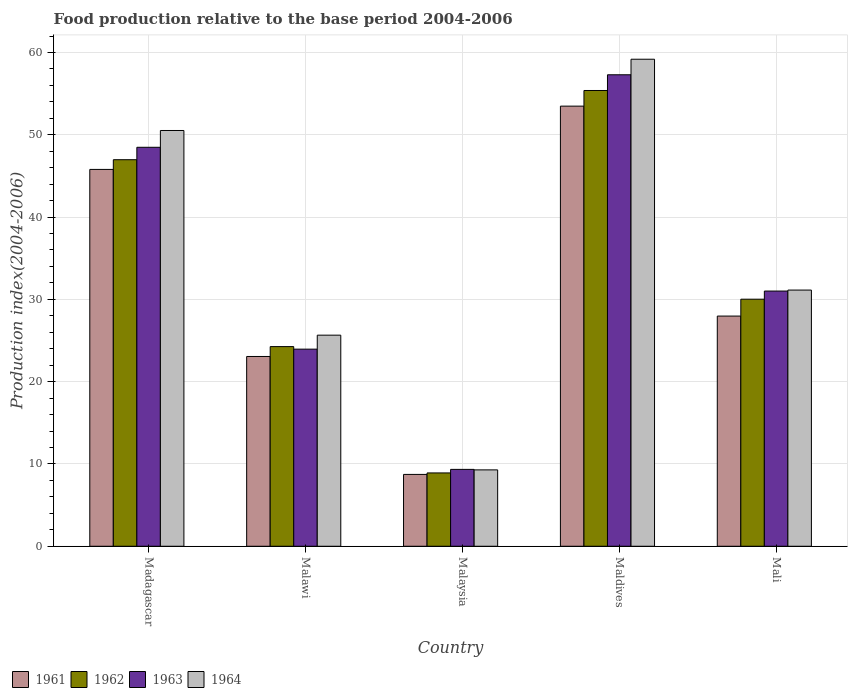How many different coloured bars are there?
Provide a succinct answer. 4. Are the number of bars per tick equal to the number of legend labels?
Provide a short and direct response. Yes. How many bars are there on the 4th tick from the left?
Provide a short and direct response. 4. What is the label of the 1st group of bars from the left?
Give a very brief answer. Madagascar. What is the food production index in 1962 in Malawi?
Provide a short and direct response. 24.26. Across all countries, what is the maximum food production index in 1961?
Provide a short and direct response. 53.48. Across all countries, what is the minimum food production index in 1961?
Offer a very short reply. 8.73. In which country was the food production index in 1961 maximum?
Ensure brevity in your answer.  Maldives. In which country was the food production index in 1961 minimum?
Your response must be concise. Malaysia. What is the total food production index in 1963 in the graph?
Provide a short and direct response. 170.07. What is the difference between the food production index in 1963 in Madagascar and that in Maldives?
Offer a terse response. -8.81. What is the difference between the food production index in 1961 in Madagascar and the food production index in 1962 in Mali?
Ensure brevity in your answer.  15.77. What is the average food production index in 1962 per country?
Your answer should be compact. 33.11. What is the difference between the food production index of/in 1964 and food production index of/in 1961 in Maldives?
Provide a succinct answer. 5.7. In how many countries, is the food production index in 1963 greater than 44?
Make the answer very short. 2. What is the ratio of the food production index in 1961 in Madagascar to that in Maldives?
Ensure brevity in your answer.  0.86. What is the difference between the highest and the second highest food production index in 1962?
Your response must be concise. -16.95. What is the difference between the highest and the lowest food production index in 1961?
Provide a succinct answer. 44.75. What does the 3rd bar from the left in Mali represents?
Make the answer very short. 1963. How many bars are there?
Give a very brief answer. 20. How many countries are there in the graph?
Offer a very short reply. 5. What is the difference between two consecutive major ticks on the Y-axis?
Your answer should be compact. 10. Where does the legend appear in the graph?
Give a very brief answer. Bottom left. What is the title of the graph?
Your answer should be very brief. Food production relative to the base period 2004-2006. What is the label or title of the X-axis?
Keep it short and to the point. Country. What is the label or title of the Y-axis?
Provide a short and direct response. Production index(2004-2006). What is the Production index(2004-2006) in 1961 in Madagascar?
Provide a short and direct response. 45.79. What is the Production index(2004-2006) of 1962 in Madagascar?
Make the answer very short. 46.97. What is the Production index(2004-2006) of 1963 in Madagascar?
Ensure brevity in your answer.  48.48. What is the Production index(2004-2006) of 1964 in Madagascar?
Ensure brevity in your answer.  50.52. What is the Production index(2004-2006) in 1961 in Malawi?
Give a very brief answer. 23.06. What is the Production index(2004-2006) in 1962 in Malawi?
Keep it short and to the point. 24.26. What is the Production index(2004-2006) of 1963 in Malawi?
Your answer should be compact. 23.95. What is the Production index(2004-2006) in 1964 in Malawi?
Provide a short and direct response. 25.65. What is the Production index(2004-2006) of 1961 in Malaysia?
Your answer should be compact. 8.73. What is the Production index(2004-2006) of 1962 in Malaysia?
Make the answer very short. 8.91. What is the Production index(2004-2006) of 1963 in Malaysia?
Your answer should be very brief. 9.34. What is the Production index(2004-2006) in 1964 in Malaysia?
Keep it short and to the point. 9.28. What is the Production index(2004-2006) in 1961 in Maldives?
Offer a very short reply. 53.48. What is the Production index(2004-2006) in 1962 in Maldives?
Keep it short and to the point. 55.38. What is the Production index(2004-2006) in 1963 in Maldives?
Your answer should be very brief. 57.29. What is the Production index(2004-2006) in 1964 in Maldives?
Make the answer very short. 59.18. What is the Production index(2004-2006) in 1961 in Mali?
Your response must be concise. 27.97. What is the Production index(2004-2006) of 1962 in Mali?
Keep it short and to the point. 30.02. What is the Production index(2004-2006) of 1963 in Mali?
Offer a terse response. 31.01. What is the Production index(2004-2006) in 1964 in Mali?
Offer a terse response. 31.13. Across all countries, what is the maximum Production index(2004-2006) of 1961?
Your response must be concise. 53.48. Across all countries, what is the maximum Production index(2004-2006) in 1962?
Make the answer very short. 55.38. Across all countries, what is the maximum Production index(2004-2006) of 1963?
Your answer should be compact. 57.29. Across all countries, what is the maximum Production index(2004-2006) in 1964?
Give a very brief answer. 59.18. Across all countries, what is the minimum Production index(2004-2006) in 1961?
Give a very brief answer. 8.73. Across all countries, what is the minimum Production index(2004-2006) of 1962?
Make the answer very short. 8.91. Across all countries, what is the minimum Production index(2004-2006) in 1963?
Your answer should be compact. 9.34. Across all countries, what is the minimum Production index(2004-2006) of 1964?
Give a very brief answer. 9.28. What is the total Production index(2004-2006) of 1961 in the graph?
Make the answer very short. 159.03. What is the total Production index(2004-2006) in 1962 in the graph?
Give a very brief answer. 165.54. What is the total Production index(2004-2006) in 1963 in the graph?
Your answer should be very brief. 170.07. What is the total Production index(2004-2006) of 1964 in the graph?
Ensure brevity in your answer.  175.76. What is the difference between the Production index(2004-2006) of 1961 in Madagascar and that in Malawi?
Provide a short and direct response. 22.73. What is the difference between the Production index(2004-2006) in 1962 in Madagascar and that in Malawi?
Make the answer very short. 22.71. What is the difference between the Production index(2004-2006) in 1963 in Madagascar and that in Malawi?
Keep it short and to the point. 24.53. What is the difference between the Production index(2004-2006) of 1964 in Madagascar and that in Malawi?
Give a very brief answer. 24.87. What is the difference between the Production index(2004-2006) of 1961 in Madagascar and that in Malaysia?
Make the answer very short. 37.06. What is the difference between the Production index(2004-2006) in 1962 in Madagascar and that in Malaysia?
Offer a terse response. 38.06. What is the difference between the Production index(2004-2006) of 1963 in Madagascar and that in Malaysia?
Your answer should be compact. 39.14. What is the difference between the Production index(2004-2006) in 1964 in Madagascar and that in Malaysia?
Your answer should be very brief. 41.24. What is the difference between the Production index(2004-2006) of 1961 in Madagascar and that in Maldives?
Give a very brief answer. -7.69. What is the difference between the Production index(2004-2006) in 1962 in Madagascar and that in Maldives?
Your answer should be compact. -8.41. What is the difference between the Production index(2004-2006) in 1963 in Madagascar and that in Maldives?
Provide a short and direct response. -8.81. What is the difference between the Production index(2004-2006) in 1964 in Madagascar and that in Maldives?
Keep it short and to the point. -8.66. What is the difference between the Production index(2004-2006) of 1961 in Madagascar and that in Mali?
Ensure brevity in your answer.  17.82. What is the difference between the Production index(2004-2006) in 1962 in Madagascar and that in Mali?
Ensure brevity in your answer.  16.95. What is the difference between the Production index(2004-2006) in 1963 in Madagascar and that in Mali?
Ensure brevity in your answer.  17.47. What is the difference between the Production index(2004-2006) in 1964 in Madagascar and that in Mali?
Provide a succinct answer. 19.39. What is the difference between the Production index(2004-2006) of 1961 in Malawi and that in Malaysia?
Make the answer very short. 14.33. What is the difference between the Production index(2004-2006) in 1962 in Malawi and that in Malaysia?
Give a very brief answer. 15.35. What is the difference between the Production index(2004-2006) of 1963 in Malawi and that in Malaysia?
Your answer should be compact. 14.61. What is the difference between the Production index(2004-2006) in 1964 in Malawi and that in Malaysia?
Offer a terse response. 16.37. What is the difference between the Production index(2004-2006) of 1961 in Malawi and that in Maldives?
Offer a terse response. -30.42. What is the difference between the Production index(2004-2006) of 1962 in Malawi and that in Maldives?
Provide a succinct answer. -31.12. What is the difference between the Production index(2004-2006) of 1963 in Malawi and that in Maldives?
Make the answer very short. -33.34. What is the difference between the Production index(2004-2006) in 1964 in Malawi and that in Maldives?
Provide a short and direct response. -33.53. What is the difference between the Production index(2004-2006) of 1961 in Malawi and that in Mali?
Provide a succinct answer. -4.91. What is the difference between the Production index(2004-2006) of 1962 in Malawi and that in Mali?
Make the answer very short. -5.76. What is the difference between the Production index(2004-2006) of 1963 in Malawi and that in Mali?
Make the answer very short. -7.06. What is the difference between the Production index(2004-2006) in 1964 in Malawi and that in Mali?
Ensure brevity in your answer.  -5.48. What is the difference between the Production index(2004-2006) in 1961 in Malaysia and that in Maldives?
Your response must be concise. -44.75. What is the difference between the Production index(2004-2006) of 1962 in Malaysia and that in Maldives?
Offer a terse response. -46.47. What is the difference between the Production index(2004-2006) of 1963 in Malaysia and that in Maldives?
Provide a short and direct response. -47.95. What is the difference between the Production index(2004-2006) of 1964 in Malaysia and that in Maldives?
Keep it short and to the point. -49.9. What is the difference between the Production index(2004-2006) of 1961 in Malaysia and that in Mali?
Keep it short and to the point. -19.24. What is the difference between the Production index(2004-2006) in 1962 in Malaysia and that in Mali?
Make the answer very short. -21.11. What is the difference between the Production index(2004-2006) in 1963 in Malaysia and that in Mali?
Your answer should be very brief. -21.67. What is the difference between the Production index(2004-2006) of 1964 in Malaysia and that in Mali?
Keep it short and to the point. -21.85. What is the difference between the Production index(2004-2006) of 1961 in Maldives and that in Mali?
Ensure brevity in your answer.  25.51. What is the difference between the Production index(2004-2006) of 1962 in Maldives and that in Mali?
Give a very brief answer. 25.36. What is the difference between the Production index(2004-2006) of 1963 in Maldives and that in Mali?
Ensure brevity in your answer.  26.28. What is the difference between the Production index(2004-2006) of 1964 in Maldives and that in Mali?
Keep it short and to the point. 28.05. What is the difference between the Production index(2004-2006) of 1961 in Madagascar and the Production index(2004-2006) of 1962 in Malawi?
Provide a short and direct response. 21.53. What is the difference between the Production index(2004-2006) in 1961 in Madagascar and the Production index(2004-2006) in 1963 in Malawi?
Keep it short and to the point. 21.84. What is the difference between the Production index(2004-2006) of 1961 in Madagascar and the Production index(2004-2006) of 1964 in Malawi?
Provide a succinct answer. 20.14. What is the difference between the Production index(2004-2006) in 1962 in Madagascar and the Production index(2004-2006) in 1963 in Malawi?
Offer a terse response. 23.02. What is the difference between the Production index(2004-2006) in 1962 in Madagascar and the Production index(2004-2006) in 1964 in Malawi?
Your answer should be very brief. 21.32. What is the difference between the Production index(2004-2006) of 1963 in Madagascar and the Production index(2004-2006) of 1964 in Malawi?
Your answer should be compact. 22.83. What is the difference between the Production index(2004-2006) of 1961 in Madagascar and the Production index(2004-2006) of 1962 in Malaysia?
Keep it short and to the point. 36.88. What is the difference between the Production index(2004-2006) in 1961 in Madagascar and the Production index(2004-2006) in 1963 in Malaysia?
Provide a short and direct response. 36.45. What is the difference between the Production index(2004-2006) of 1961 in Madagascar and the Production index(2004-2006) of 1964 in Malaysia?
Ensure brevity in your answer.  36.51. What is the difference between the Production index(2004-2006) of 1962 in Madagascar and the Production index(2004-2006) of 1963 in Malaysia?
Provide a succinct answer. 37.63. What is the difference between the Production index(2004-2006) in 1962 in Madagascar and the Production index(2004-2006) in 1964 in Malaysia?
Give a very brief answer. 37.69. What is the difference between the Production index(2004-2006) in 1963 in Madagascar and the Production index(2004-2006) in 1964 in Malaysia?
Your response must be concise. 39.2. What is the difference between the Production index(2004-2006) in 1961 in Madagascar and the Production index(2004-2006) in 1962 in Maldives?
Provide a succinct answer. -9.59. What is the difference between the Production index(2004-2006) of 1961 in Madagascar and the Production index(2004-2006) of 1964 in Maldives?
Give a very brief answer. -13.39. What is the difference between the Production index(2004-2006) of 1962 in Madagascar and the Production index(2004-2006) of 1963 in Maldives?
Your response must be concise. -10.32. What is the difference between the Production index(2004-2006) in 1962 in Madagascar and the Production index(2004-2006) in 1964 in Maldives?
Keep it short and to the point. -12.21. What is the difference between the Production index(2004-2006) of 1961 in Madagascar and the Production index(2004-2006) of 1962 in Mali?
Your response must be concise. 15.77. What is the difference between the Production index(2004-2006) of 1961 in Madagascar and the Production index(2004-2006) of 1963 in Mali?
Make the answer very short. 14.78. What is the difference between the Production index(2004-2006) of 1961 in Madagascar and the Production index(2004-2006) of 1964 in Mali?
Provide a short and direct response. 14.66. What is the difference between the Production index(2004-2006) in 1962 in Madagascar and the Production index(2004-2006) in 1963 in Mali?
Provide a succinct answer. 15.96. What is the difference between the Production index(2004-2006) in 1962 in Madagascar and the Production index(2004-2006) in 1964 in Mali?
Make the answer very short. 15.84. What is the difference between the Production index(2004-2006) in 1963 in Madagascar and the Production index(2004-2006) in 1964 in Mali?
Provide a short and direct response. 17.35. What is the difference between the Production index(2004-2006) of 1961 in Malawi and the Production index(2004-2006) of 1962 in Malaysia?
Your response must be concise. 14.15. What is the difference between the Production index(2004-2006) of 1961 in Malawi and the Production index(2004-2006) of 1963 in Malaysia?
Give a very brief answer. 13.72. What is the difference between the Production index(2004-2006) of 1961 in Malawi and the Production index(2004-2006) of 1964 in Malaysia?
Your response must be concise. 13.78. What is the difference between the Production index(2004-2006) of 1962 in Malawi and the Production index(2004-2006) of 1963 in Malaysia?
Provide a short and direct response. 14.92. What is the difference between the Production index(2004-2006) of 1962 in Malawi and the Production index(2004-2006) of 1964 in Malaysia?
Your response must be concise. 14.98. What is the difference between the Production index(2004-2006) in 1963 in Malawi and the Production index(2004-2006) in 1964 in Malaysia?
Provide a short and direct response. 14.67. What is the difference between the Production index(2004-2006) of 1961 in Malawi and the Production index(2004-2006) of 1962 in Maldives?
Offer a terse response. -32.32. What is the difference between the Production index(2004-2006) of 1961 in Malawi and the Production index(2004-2006) of 1963 in Maldives?
Ensure brevity in your answer.  -34.23. What is the difference between the Production index(2004-2006) of 1961 in Malawi and the Production index(2004-2006) of 1964 in Maldives?
Your answer should be very brief. -36.12. What is the difference between the Production index(2004-2006) in 1962 in Malawi and the Production index(2004-2006) in 1963 in Maldives?
Provide a succinct answer. -33.03. What is the difference between the Production index(2004-2006) of 1962 in Malawi and the Production index(2004-2006) of 1964 in Maldives?
Offer a very short reply. -34.92. What is the difference between the Production index(2004-2006) of 1963 in Malawi and the Production index(2004-2006) of 1964 in Maldives?
Give a very brief answer. -35.23. What is the difference between the Production index(2004-2006) of 1961 in Malawi and the Production index(2004-2006) of 1962 in Mali?
Offer a very short reply. -6.96. What is the difference between the Production index(2004-2006) in 1961 in Malawi and the Production index(2004-2006) in 1963 in Mali?
Make the answer very short. -7.95. What is the difference between the Production index(2004-2006) in 1961 in Malawi and the Production index(2004-2006) in 1964 in Mali?
Keep it short and to the point. -8.07. What is the difference between the Production index(2004-2006) of 1962 in Malawi and the Production index(2004-2006) of 1963 in Mali?
Ensure brevity in your answer.  -6.75. What is the difference between the Production index(2004-2006) in 1962 in Malawi and the Production index(2004-2006) in 1964 in Mali?
Give a very brief answer. -6.87. What is the difference between the Production index(2004-2006) of 1963 in Malawi and the Production index(2004-2006) of 1964 in Mali?
Your response must be concise. -7.18. What is the difference between the Production index(2004-2006) in 1961 in Malaysia and the Production index(2004-2006) in 1962 in Maldives?
Ensure brevity in your answer.  -46.65. What is the difference between the Production index(2004-2006) in 1961 in Malaysia and the Production index(2004-2006) in 1963 in Maldives?
Offer a very short reply. -48.56. What is the difference between the Production index(2004-2006) in 1961 in Malaysia and the Production index(2004-2006) in 1964 in Maldives?
Give a very brief answer. -50.45. What is the difference between the Production index(2004-2006) in 1962 in Malaysia and the Production index(2004-2006) in 1963 in Maldives?
Offer a terse response. -48.38. What is the difference between the Production index(2004-2006) of 1962 in Malaysia and the Production index(2004-2006) of 1964 in Maldives?
Make the answer very short. -50.27. What is the difference between the Production index(2004-2006) of 1963 in Malaysia and the Production index(2004-2006) of 1964 in Maldives?
Keep it short and to the point. -49.84. What is the difference between the Production index(2004-2006) in 1961 in Malaysia and the Production index(2004-2006) in 1962 in Mali?
Ensure brevity in your answer.  -21.29. What is the difference between the Production index(2004-2006) in 1961 in Malaysia and the Production index(2004-2006) in 1963 in Mali?
Your answer should be compact. -22.28. What is the difference between the Production index(2004-2006) in 1961 in Malaysia and the Production index(2004-2006) in 1964 in Mali?
Give a very brief answer. -22.4. What is the difference between the Production index(2004-2006) in 1962 in Malaysia and the Production index(2004-2006) in 1963 in Mali?
Provide a short and direct response. -22.1. What is the difference between the Production index(2004-2006) of 1962 in Malaysia and the Production index(2004-2006) of 1964 in Mali?
Provide a short and direct response. -22.22. What is the difference between the Production index(2004-2006) in 1963 in Malaysia and the Production index(2004-2006) in 1964 in Mali?
Keep it short and to the point. -21.79. What is the difference between the Production index(2004-2006) of 1961 in Maldives and the Production index(2004-2006) of 1962 in Mali?
Make the answer very short. 23.46. What is the difference between the Production index(2004-2006) of 1961 in Maldives and the Production index(2004-2006) of 1963 in Mali?
Your answer should be compact. 22.47. What is the difference between the Production index(2004-2006) of 1961 in Maldives and the Production index(2004-2006) of 1964 in Mali?
Your answer should be compact. 22.35. What is the difference between the Production index(2004-2006) in 1962 in Maldives and the Production index(2004-2006) in 1963 in Mali?
Provide a succinct answer. 24.37. What is the difference between the Production index(2004-2006) of 1962 in Maldives and the Production index(2004-2006) of 1964 in Mali?
Provide a short and direct response. 24.25. What is the difference between the Production index(2004-2006) of 1963 in Maldives and the Production index(2004-2006) of 1964 in Mali?
Provide a succinct answer. 26.16. What is the average Production index(2004-2006) of 1961 per country?
Offer a very short reply. 31.81. What is the average Production index(2004-2006) in 1962 per country?
Your response must be concise. 33.11. What is the average Production index(2004-2006) in 1963 per country?
Your answer should be very brief. 34.01. What is the average Production index(2004-2006) in 1964 per country?
Provide a short and direct response. 35.15. What is the difference between the Production index(2004-2006) of 1961 and Production index(2004-2006) of 1962 in Madagascar?
Give a very brief answer. -1.18. What is the difference between the Production index(2004-2006) of 1961 and Production index(2004-2006) of 1963 in Madagascar?
Provide a short and direct response. -2.69. What is the difference between the Production index(2004-2006) of 1961 and Production index(2004-2006) of 1964 in Madagascar?
Offer a terse response. -4.73. What is the difference between the Production index(2004-2006) in 1962 and Production index(2004-2006) in 1963 in Madagascar?
Your answer should be compact. -1.51. What is the difference between the Production index(2004-2006) in 1962 and Production index(2004-2006) in 1964 in Madagascar?
Keep it short and to the point. -3.55. What is the difference between the Production index(2004-2006) in 1963 and Production index(2004-2006) in 1964 in Madagascar?
Provide a short and direct response. -2.04. What is the difference between the Production index(2004-2006) in 1961 and Production index(2004-2006) in 1962 in Malawi?
Provide a succinct answer. -1.2. What is the difference between the Production index(2004-2006) in 1961 and Production index(2004-2006) in 1963 in Malawi?
Your answer should be very brief. -0.89. What is the difference between the Production index(2004-2006) in 1961 and Production index(2004-2006) in 1964 in Malawi?
Offer a terse response. -2.59. What is the difference between the Production index(2004-2006) in 1962 and Production index(2004-2006) in 1963 in Malawi?
Provide a short and direct response. 0.31. What is the difference between the Production index(2004-2006) in 1962 and Production index(2004-2006) in 1964 in Malawi?
Offer a very short reply. -1.39. What is the difference between the Production index(2004-2006) of 1961 and Production index(2004-2006) of 1962 in Malaysia?
Offer a terse response. -0.18. What is the difference between the Production index(2004-2006) of 1961 and Production index(2004-2006) of 1963 in Malaysia?
Provide a short and direct response. -0.61. What is the difference between the Production index(2004-2006) in 1961 and Production index(2004-2006) in 1964 in Malaysia?
Your response must be concise. -0.55. What is the difference between the Production index(2004-2006) of 1962 and Production index(2004-2006) of 1963 in Malaysia?
Give a very brief answer. -0.43. What is the difference between the Production index(2004-2006) of 1962 and Production index(2004-2006) of 1964 in Malaysia?
Give a very brief answer. -0.37. What is the difference between the Production index(2004-2006) of 1961 and Production index(2004-2006) of 1962 in Maldives?
Make the answer very short. -1.9. What is the difference between the Production index(2004-2006) in 1961 and Production index(2004-2006) in 1963 in Maldives?
Offer a very short reply. -3.81. What is the difference between the Production index(2004-2006) of 1961 and Production index(2004-2006) of 1964 in Maldives?
Provide a short and direct response. -5.7. What is the difference between the Production index(2004-2006) of 1962 and Production index(2004-2006) of 1963 in Maldives?
Give a very brief answer. -1.91. What is the difference between the Production index(2004-2006) in 1963 and Production index(2004-2006) in 1964 in Maldives?
Ensure brevity in your answer.  -1.89. What is the difference between the Production index(2004-2006) in 1961 and Production index(2004-2006) in 1962 in Mali?
Your answer should be very brief. -2.05. What is the difference between the Production index(2004-2006) in 1961 and Production index(2004-2006) in 1963 in Mali?
Offer a terse response. -3.04. What is the difference between the Production index(2004-2006) of 1961 and Production index(2004-2006) of 1964 in Mali?
Keep it short and to the point. -3.16. What is the difference between the Production index(2004-2006) of 1962 and Production index(2004-2006) of 1963 in Mali?
Give a very brief answer. -0.99. What is the difference between the Production index(2004-2006) in 1962 and Production index(2004-2006) in 1964 in Mali?
Your response must be concise. -1.11. What is the difference between the Production index(2004-2006) in 1963 and Production index(2004-2006) in 1964 in Mali?
Your answer should be compact. -0.12. What is the ratio of the Production index(2004-2006) of 1961 in Madagascar to that in Malawi?
Keep it short and to the point. 1.99. What is the ratio of the Production index(2004-2006) in 1962 in Madagascar to that in Malawi?
Provide a succinct answer. 1.94. What is the ratio of the Production index(2004-2006) in 1963 in Madagascar to that in Malawi?
Make the answer very short. 2.02. What is the ratio of the Production index(2004-2006) in 1964 in Madagascar to that in Malawi?
Offer a very short reply. 1.97. What is the ratio of the Production index(2004-2006) of 1961 in Madagascar to that in Malaysia?
Provide a succinct answer. 5.25. What is the ratio of the Production index(2004-2006) in 1962 in Madagascar to that in Malaysia?
Your response must be concise. 5.27. What is the ratio of the Production index(2004-2006) of 1963 in Madagascar to that in Malaysia?
Your answer should be compact. 5.19. What is the ratio of the Production index(2004-2006) of 1964 in Madagascar to that in Malaysia?
Your response must be concise. 5.44. What is the ratio of the Production index(2004-2006) in 1961 in Madagascar to that in Maldives?
Make the answer very short. 0.86. What is the ratio of the Production index(2004-2006) of 1962 in Madagascar to that in Maldives?
Your answer should be very brief. 0.85. What is the ratio of the Production index(2004-2006) of 1963 in Madagascar to that in Maldives?
Give a very brief answer. 0.85. What is the ratio of the Production index(2004-2006) in 1964 in Madagascar to that in Maldives?
Provide a succinct answer. 0.85. What is the ratio of the Production index(2004-2006) in 1961 in Madagascar to that in Mali?
Your response must be concise. 1.64. What is the ratio of the Production index(2004-2006) in 1962 in Madagascar to that in Mali?
Ensure brevity in your answer.  1.56. What is the ratio of the Production index(2004-2006) in 1963 in Madagascar to that in Mali?
Give a very brief answer. 1.56. What is the ratio of the Production index(2004-2006) of 1964 in Madagascar to that in Mali?
Your response must be concise. 1.62. What is the ratio of the Production index(2004-2006) in 1961 in Malawi to that in Malaysia?
Ensure brevity in your answer.  2.64. What is the ratio of the Production index(2004-2006) of 1962 in Malawi to that in Malaysia?
Your answer should be very brief. 2.72. What is the ratio of the Production index(2004-2006) of 1963 in Malawi to that in Malaysia?
Keep it short and to the point. 2.56. What is the ratio of the Production index(2004-2006) in 1964 in Malawi to that in Malaysia?
Your response must be concise. 2.76. What is the ratio of the Production index(2004-2006) in 1961 in Malawi to that in Maldives?
Ensure brevity in your answer.  0.43. What is the ratio of the Production index(2004-2006) in 1962 in Malawi to that in Maldives?
Provide a short and direct response. 0.44. What is the ratio of the Production index(2004-2006) of 1963 in Malawi to that in Maldives?
Keep it short and to the point. 0.42. What is the ratio of the Production index(2004-2006) in 1964 in Malawi to that in Maldives?
Give a very brief answer. 0.43. What is the ratio of the Production index(2004-2006) of 1961 in Malawi to that in Mali?
Give a very brief answer. 0.82. What is the ratio of the Production index(2004-2006) in 1962 in Malawi to that in Mali?
Keep it short and to the point. 0.81. What is the ratio of the Production index(2004-2006) of 1963 in Malawi to that in Mali?
Offer a terse response. 0.77. What is the ratio of the Production index(2004-2006) in 1964 in Malawi to that in Mali?
Offer a terse response. 0.82. What is the ratio of the Production index(2004-2006) of 1961 in Malaysia to that in Maldives?
Ensure brevity in your answer.  0.16. What is the ratio of the Production index(2004-2006) of 1962 in Malaysia to that in Maldives?
Offer a very short reply. 0.16. What is the ratio of the Production index(2004-2006) in 1963 in Malaysia to that in Maldives?
Your answer should be compact. 0.16. What is the ratio of the Production index(2004-2006) of 1964 in Malaysia to that in Maldives?
Your response must be concise. 0.16. What is the ratio of the Production index(2004-2006) of 1961 in Malaysia to that in Mali?
Your answer should be compact. 0.31. What is the ratio of the Production index(2004-2006) of 1962 in Malaysia to that in Mali?
Your answer should be very brief. 0.3. What is the ratio of the Production index(2004-2006) of 1963 in Malaysia to that in Mali?
Provide a short and direct response. 0.3. What is the ratio of the Production index(2004-2006) of 1964 in Malaysia to that in Mali?
Provide a short and direct response. 0.3. What is the ratio of the Production index(2004-2006) in 1961 in Maldives to that in Mali?
Give a very brief answer. 1.91. What is the ratio of the Production index(2004-2006) of 1962 in Maldives to that in Mali?
Offer a very short reply. 1.84. What is the ratio of the Production index(2004-2006) in 1963 in Maldives to that in Mali?
Offer a very short reply. 1.85. What is the ratio of the Production index(2004-2006) in 1964 in Maldives to that in Mali?
Provide a succinct answer. 1.9. What is the difference between the highest and the second highest Production index(2004-2006) of 1961?
Keep it short and to the point. 7.69. What is the difference between the highest and the second highest Production index(2004-2006) in 1962?
Give a very brief answer. 8.41. What is the difference between the highest and the second highest Production index(2004-2006) in 1963?
Your answer should be compact. 8.81. What is the difference between the highest and the second highest Production index(2004-2006) in 1964?
Your answer should be compact. 8.66. What is the difference between the highest and the lowest Production index(2004-2006) of 1961?
Give a very brief answer. 44.75. What is the difference between the highest and the lowest Production index(2004-2006) in 1962?
Offer a very short reply. 46.47. What is the difference between the highest and the lowest Production index(2004-2006) in 1963?
Give a very brief answer. 47.95. What is the difference between the highest and the lowest Production index(2004-2006) in 1964?
Your response must be concise. 49.9. 